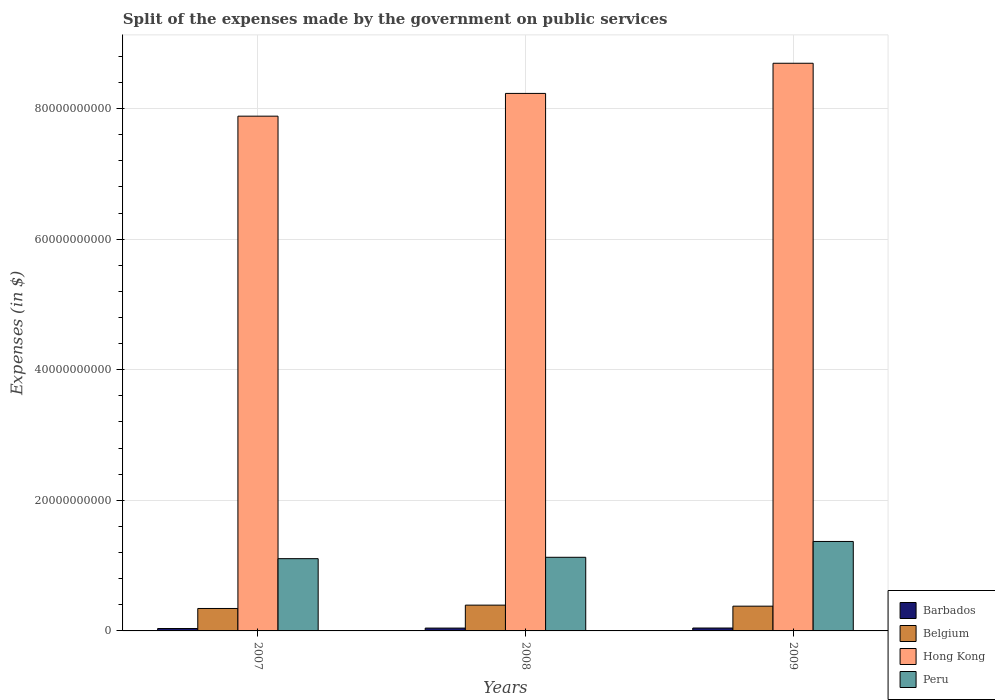How many different coloured bars are there?
Your response must be concise. 4. How many groups of bars are there?
Provide a succinct answer. 3. How many bars are there on the 2nd tick from the left?
Give a very brief answer. 4. What is the label of the 3rd group of bars from the left?
Make the answer very short. 2009. What is the expenses made by the government on public services in Peru in 2007?
Ensure brevity in your answer.  1.11e+1. Across all years, what is the maximum expenses made by the government on public services in Belgium?
Provide a short and direct response. 3.95e+09. Across all years, what is the minimum expenses made by the government on public services in Hong Kong?
Your answer should be compact. 7.88e+1. In which year was the expenses made by the government on public services in Belgium maximum?
Your response must be concise. 2008. What is the total expenses made by the government on public services in Belgium in the graph?
Make the answer very short. 1.12e+1. What is the difference between the expenses made by the government on public services in Belgium in 2008 and that in 2009?
Provide a short and direct response. 1.58e+08. What is the difference between the expenses made by the government on public services in Peru in 2008 and the expenses made by the government on public services in Belgium in 2007?
Your answer should be compact. 7.84e+09. What is the average expenses made by the government on public services in Belgium per year?
Keep it short and to the point. 3.73e+09. In the year 2009, what is the difference between the expenses made by the government on public services in Barbados and expenses made by the government on public services in Hong Kong?
Your response must be concise. -8.65e+1. In how many years, is the expenses made by the government on public services in Barbados greater than 20000000000 $?
Offer a very short reply. 0. What is the ratio of the expenses made by the government on public services in Barbados in 2007 to that in 2009?
Your answer should be compact. 0.83. Is the expenses made by the government on public services in Hong Kong in 2008 less than that in 2009?
Keep it short and to the point. Yes. What is the difference between the highest and the second highest expenses made by the government on public services in Hong Kong?
Your answer should be very brief. 4.62e+09. What is the difference between the highest and the lowest expenses made by the government on public services in Barbados?
Make the answer very short. 7.74e+07. Is it the case that in every year, the sum of the expenses made by the government on public services in Barbados and expenses made by the government on public services in Hong Kong is greater than the sum of expenses made by the government on public services in Belgium and expenses made by the government on public services in Peru?
Ensure brevity in your answer.  No. What does the 1st bar from the left in 2008 represents?
Your response must be concise. Barbados. What does the 2nd bar from the right in 2008 represents?
Keep it short and to the point. Hong Kong. How many bars are there?
Provide a succinct answer. 12. How many years are there in the graph?
Provide a succinct answer. 3. Are the values on the major ticks of Y-axis written in scientific E-notation?
Keep it short and to the point. No. Does the graph contain grids?
Give a very brief answer. Yes. Where does the legend appear in the graph?
Ensure brevity in your answer.  Bottom right. What is the title of the graph?
Offer a terse response. Split of the expenses made by the government on public services. What is the label or title of the X-axis?
Give a very brief answer. Years. What is the label or title of the Y-axis?
Make the answer very short. Expenses (in $). What is the Expenses (in $) in Barbados in 2007?
Keep it short and to the point. 3.67e+08. What is the Expenses (in $) in Belgium in 2007?
Keep it short and to the point. 3.44e+09. What is the Expenses (in $) of Hong Kong in 2007?
Offer a very short reply. 7.88e+1. What is the Expenses (in $) in Peru in 2007?
Provide a succinct answer. 1.11e+1. What is the Expenses (in $) in Barbados in 2008?
Ensure brevity in your answer.  4.35e+08. What is the Expenses (in $) in Belgium in 2008?
Give a very brief answer. 3.95e+09. What is the Expenses (in $) in Hong Kong in 2008?
Offer a very short reply. 8.23e+1. What is the Expenses (in $) in Peru in 2008?
Give a very brief answer. 1.13e+1. What is the Expenses (in $) in Barbados in 2009?
Your answer should be very brief. 4.44e+08. What is the Expenses (in $) of Belgium in 2009?
Provide a succinct answer. 3.79e+09. What is the Expenses (in $) in Hong Kong in 2009?
Offer a very short reply. 8.69e+1. What is the Expenses (in $) of Peru in 2009?
Your response must be concise. 1.37e+1. Across all years, what is the maximum Expenses (in $) in Barbados?
Provide a short and direct response. 4.44e+08. Across all years, what is the maximum Expenses (in $) of Belgium?
Provide a short and direct response. 3.95e+09. Across all years, what is the maximum Expenses (in $) in Hong Kong?
Keep it short and to the point. 8.69e+1. Across all years, what is the maximum Expenses (in $) in Peru?
Give a very brief answer. 1.37e+1. Across all years, what is the minimum Expenses (in $) of Barbados?
Your answer should be compact. 3.67e+08. Across all years, what is the minimum Expenses (in $) of Belgium?
Your answer should be compact. 3.44e+09. Across all years, what is the minimum Expenses (in $) of Hong Kong?
Your response must be concise. 7.88e+1. Across all years, what is the minimum Expenses (in $) of Peru?
Provide a short and direct response. 1.11e+1. What is the total Expenses (in $) in Barbados in the graph?
Your answer should be compact. 1.25e+09. What is the total Expenses (in $) in Belgium in the graph?
Your answer should be compact. 1.12e+1. What is the total Expenses (in $) of Hong Kong in the graph?
Offer a very short reply. 2.48e+11. What is the total Expenses (in $) in Peru in the graph?
Your response must be concise. 3.60e+1. What is the difference between the Expenses (in $) in Barbados in 2007 and that in 2008?
Your answer should be compact. -6.75e+07. What is the difference between the Expenses (in $) in Belgium in 2007 and that in 2008?
Provide a short and direct response. -5.12e+08. What is the difference between the Expenses (in $) in Hong Kong in 2007 and that in 2008?
Your response must be concise. -3.48e+09. What is the difference between the Expenses (in $) of Peru in 2007 and that in 2008?
Make the answer very short. -2.11e+08. What is the difference between the Expenses (in $) of Barbados in 2007 and that in 2009?
Provide a short and direct response. -7.74e+07. What is the difference between the Expenses (in $) in Belgium in 2007 and that in 2009?
Offer a very short reply. -3.54e+08. What is the difference between the Expenses (in $) in Hong Kong in 2007 and that in 2009?
Provide a succinct answer. -8.10e+09. What is the difference between the Expenses (in $) of Peru in 2007 and that in 2009?
Your response must be concise. -2.63e+09. What is the difference between the Expenses (in $) in Barbados in 2008 and that in 2009?
Your response must be concise. -9.82e+06. What is the difference between the Expenses (in $) in Belgium in 2008 and that in 2009?
Provide a succinct answer. 1.58e+08. What is the difference between the Expenses (in $) of Hong Kong in 2008 and that in 2009?
Make the answer very short. -4.62e+09. What is the difference between the Expenses (in $) in Peru in 2008 and that in 2009?
Offer a terse response. -2.42e+09. What is the difference between the Expenses (in $) in Barbados in 2007 and the Expenses (in $) in Belgium in 2008?
Keep it short and to the point. -3.58e+09. What is the difference between the Expenses (in $) in Barbados in 2007 and the Expenses (in $) in Hong Kong in 2008?
Your answer should be compact. -8.19e+1. What is the difference between the Expenses (in $) in Barbados in 2007 and the Expenses (in $) in Peru in 2008?
Provide a succinct answer. -1.09e+1. What is the difference between the Expenses (in $) of Belgium in 2007 and the Expenses (in $) of Hong Kong in 2008?
Keep it short and to the point. -7.89e+1. What is the difference between the Expenses (in $) in Belgium in 2007 and the Expenses (in $) in Peru in 2008?
Offer a terse response. -7.84e+09. What is the difference between the Expenses (in $) in Hong Kong in 2007 and the Expenses (in $) in Peru in 2008?
Provide a succinct answer. 6.76e+1. What is the difference between the Expenses (in $) in Barbados in 2007 and the Expenses (in $) in Belgium in 2009?
Keep it short and to the point. -3.42e+09. What is the difference between the Expenses (in $) in Barbados in 2007 and the Expenses (in $) in Hong Kong in 2009?
Provide a succinct answer. -8.66e+1. What is the difference between the Expenses (in $) in Barbados in 2007 and the Expenses (in $) in Peru in 2009?
Ensure brevity in your answer.  -1.33e+1. What is the difference between the Expenses (in $) in Belgium in 2007 and the Expenses (in $) in Hong Kong in 2009?
Keep it short and to the point. -8.35e+1. What is the difference between the Expenses (in $) in Belgium in 2007 and the Expenses (in $) in Peru in 2009?
Your answer should be compact. -1.03e+1. What is the difference between the Expenses (in $) of Hong Kong in 2007 and the Expenses (in $) of Peru in 2009?
Offer a terse response. 6.51e+1. What is the difference between the Expenses (in $) of Barbados in 2008 and the Expenses (in $) of Belgium in 2009?
Provide a short and direct response. -3.36e+09. What is the difference between the Expenses (in $) of Barbados in 2008 and the Expenses (in $) of Hong Kong in 2009?
Give a very brief answer. -8.65e+1. What is the difference between the Expenses (in $) of Barbados in 2008 and the Expenses (in $) of Peru in 2009?
Ensure brevity in your answer.  -1.33e+1. What is the difference between the Expenses (in $) in Belgium in 2008 and the Expenses (in $) in Hong Kong in 2009?
Your answer should be compact. -8.30e+1. What is the difference between the Expenses (in $) of Belgium in 2008 and the Expenses (in $) of Peru in 2009?
Provide a succinct answer. -9.75e+09. What is the difference between the Expenses (in $) in Hong Kong in 2008 and the Expenses (in $) in Peru in 2009?
Ensure brevity in your answer.  6.86e+1. What is the average Expenses (in $) of Barbados per year?
Offer a very short reply. 4.15e+08. What is the average Expenses (in $) in Belgium per year?
Your answer should be compact. 3.73e+09. What is the average Expenses (in $) of Hong Kong per year?
Provide a succinct answer. 8.27e+1. What is the average Expenses (in $) in Peru per year?
Your answer should be compact. 1.20e+1. In the year 2007, what is the difference between the Expenses (in $) of Barbados and Expenses (in $) of Belgium?
Offer a terse response. -3.07e+09. In the year 2007, what is the difference between the Expenses (in $) of Barbados and Expenses (in $) of Hong Kong?
Offer a terse response. -7.85e+1. In the year 2007, what is the difference between the Expenses (in $) of Barbados and Expenses (in $) of Peru?
Offer a terse response. -1.07e+1. In the year 2007, what is the difference between the Expenses (in $) in Belgium and Expenses (in $) in Hong Kong?
Provide a succinct answer. -7.54e+1. In the year 2007, what is the difference between the Expenses (in $) in Belgium and Expenses (in $) in Peru?
Keep it short and to the point. -7.63e+09. In the year 2007, what is the difference between the Expenses (in $) in Hong Kong and Expenses (in $) in Peru?
Your answer should be very brief. 6.78e+1. In the year 2008, what is the difference between the Expenses (in $) in Barbados and Expenses (in $) in Belgium?
Ensure brevity in your answer.  -3.51e+09. In the year 2008, what is the difference between the Expenses (in $) of Barbados and Expenses (in $) of Hong Kong?
Your answer should be very brief. -8.19e+1. In the year 2008, what is the difference between the Expenses (in $) of Barbados and Expenses (in $) of Peru?
Offer a very short reply. -1.08e+1. In the year 2008, what is the difference between the Expenses (in $) in Belgium and Expenses (in $) in Hong Kong?
Make the answer very short. -7.84e+1. In the year 2008, what is the difference between the Expenses (in $) in Belgium and Expenses (in $) in Peru?
Ensure brevity in your answer.  -7.33e+09. In the year 2008, what is the difference between the Expenses (in $) in Hong Kong and Expenses (in $) in Peru?
Keep it short and to the point. 7.10e+1. In the year 2009, what is the difference between the Expenses (in $) in Barbados and Expenses (in $) in Belgium?
Give a very brief answer. -3.35e+09. In the year 2009, what is the difference between the Expenses (in $) in Barbados and Expenses (in $) in Hong Kong?
Keep it short and to the point. -8.65e+1. In the year 2009, what is the difference between the Expenses (in $) in Barbados and Expenses (in $) in Peru?
Keep it short and to the point. -1.33e+1. In the year 2009, what is the difference between the Expenses (in $) in Belgium and Expenses (in $) in Hong Kong?
Your answer should be compact. -8.31e+1. In the year 2009, what is the difference between the Expenses (in $) of Belgium and Expenses (in $) of Peru?
Provide a short and direct response. -9.91e+09. In the year 2009, what is the difference between the Expenses (in $) in Hong Kong and Expenses (in $) in Peru?
Offer a very short reply. 7.32e+1. What is the ratio of the Expenses (in $) in Barbados in 2007 to that in 2008?
Give a very brief answer. 0.84. What is the ratio of the Expenses (in $) of Belgium in 2007 to that in 2008?
Offer a terse response. 0.87. What is the ratio of the Expenses (in $) in Hong Kong in 2007 to that in 2008?
Provide a short and direct response. 0.96. What is the ratio of the Expenses (in $) in Peru in 2007 to that in 2008?
Offer a terse response. 0.98. What is the ratio of the Expenses (in $) in Barbados in 2007 to that in 2009?
Keep it short and to the point. 0.83. What is the ratio of the Expenses (in $) in Belgium in 2007 to that in 2009?
Give a very brief answer. 0.91. What is the ratio of the Expenses (in $) in Hong Kong in 2007 to that in 2009?
Provide a short and direct response. 0.91. What is the ratio of the Expenses (in $) in Peru in 2007 to that in 2009?
Your answer should be compact. 0.81. What is the ratio of the Expenses (in $) in Barbados in 2008 to that in 2009?
Your answer should be compact. 0.98. What is the ratio of the Expenses (in $) in Belgium in 2008 to that in 2009?
Your response must be concise. 1.04. What is the ratio of the Expenses (in $) of Hong Kong in 2008 to that in 2009?
Offer a very short reply. 0.95. What is the ratio of the Expenses (in $) of Peru in 2008 to that in 2009?
Provide a short and direct response. 0.82. What is the difference between the highest and the second highest Expenses (in $) of Barbados?
Offer a very short reply. 9.82e+06. What is the difference between the highest and the second highest Expenses (in $) in Belgium?
Ensure brevity in your answer.  1.58e+08. What is the difference between the highest and the second highest Expenses (in $) in Hong Kong?
Your answer should be compact. 4.62e+09. What is the difference between the highest and the second highest Expenses (in $) in Peru?
Give a very brief answer. 2.42e+09. What is the difference between the highest and the lowest Expenses (in $) in Barbados?
Ensure brevity in your answer.  7.74e+07. What is the difference between the highest and the lowest Expenses (in $) of Belgium?
Your answer should be compact. 5.12e+08. What is the difference between the highest and the lowest Expenses (in $) of Hong Kong?
Your response must be concise. 8.10e+09. What is the difference between the highest and the lowest Expenses (in $) of Peru?
Ensure brevity in your answer.  2.63e+09. 